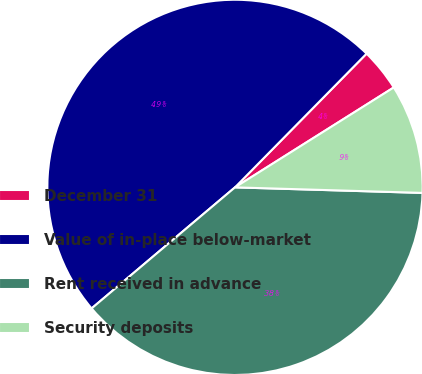Convert chart. <chart><loc_0><loc_0><loc_500><loc_500><pie_chart><fcel>December 31<fcel>Value of in-place below-market<fcel>Rent received in advance<fcel>Security deposits<nl><fcel>3.69%<fcel>48.53%<fcel>38.37%<fcel>9.41%<nl></chart> 